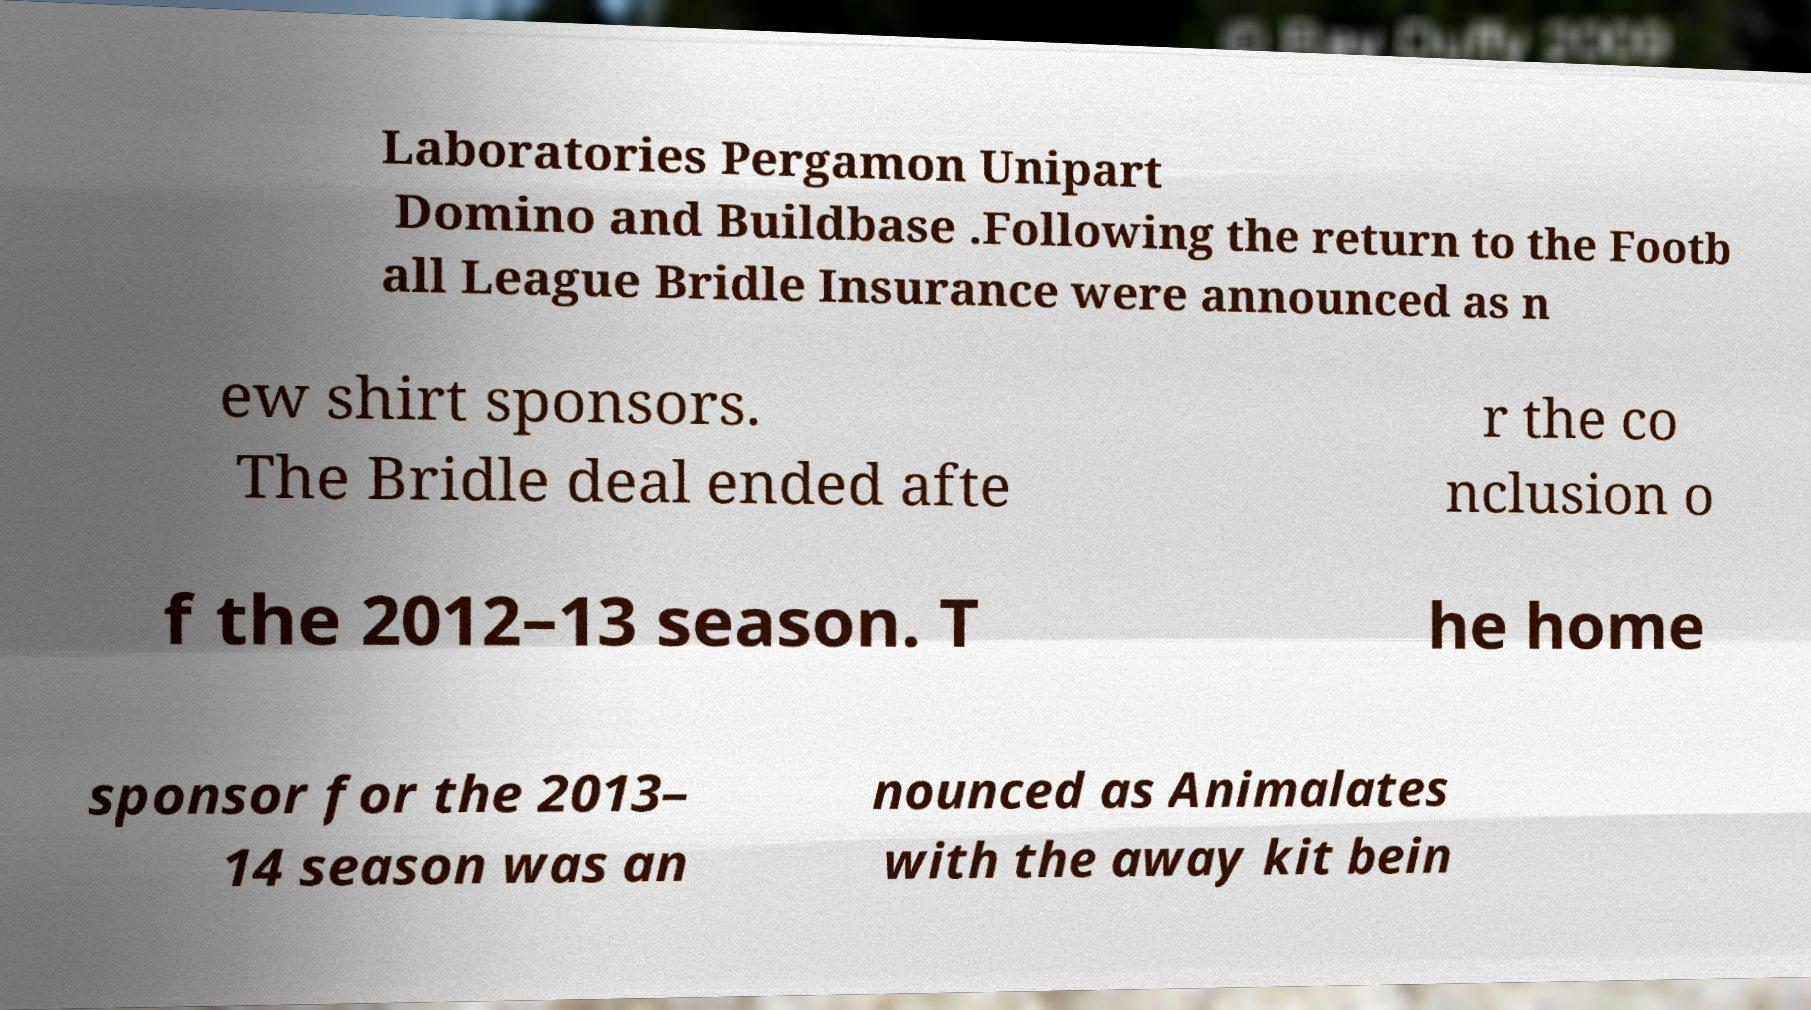What messages or text are displayed in this image? I need them in a readable, typed format. Laboratories Pergamon Unipart Domino and Buildbase .Following the return to the Footb all League Bridle Insurance were announced as n ew shirt sponsors. The Bridle deal ended afte r the co nclusion o f the 2012–13 season. T he home sponsor for the 2013– 14 season was an nounced as Animalates with the away kit bein 